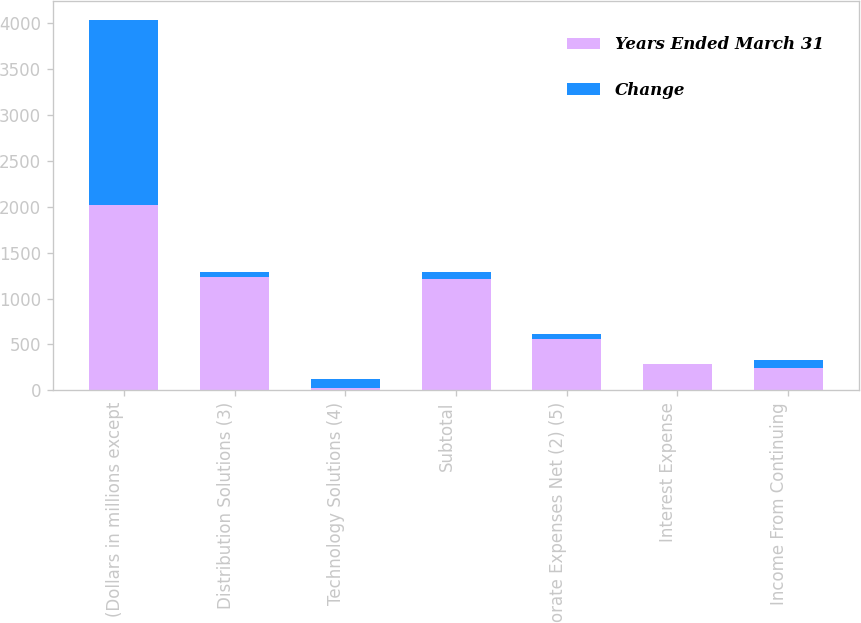Convert chart. <chart><loc_0><loc_0><loc_500><loc_500><stacked_bar_chart><ecel><fcel>(Dollars in millions except<fcel>Distribution Solutions (3)<fcel>Technology Solutions (4)<fcel>Subtotal<fcel>Corporate Expenses Net (2) (5)<fcel>Interest Expense<fcel>Income From Continuing<nl><fcel>Years Ended March 31<fcel>2018<fcel>1231<fcel>23<fcel>1208<fcel>564<fcel>283<fcel>239<nl><fcel>Change<fcel>2018<fcel>63<fcel>101<fcel>84<fcel>50<fcel>8<fcel>97<nl></chart> 